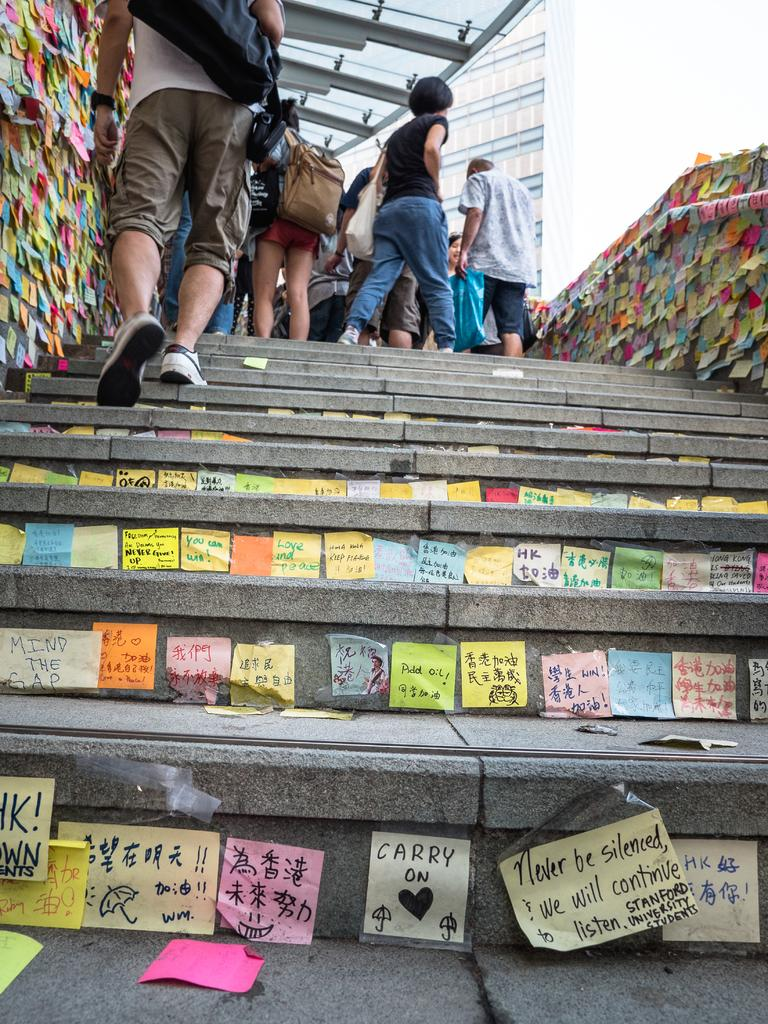<image>
Give a short and clear explanation of the subsequent image. A sticky note that says carry on is stuck to the riser of a stone staircase. 